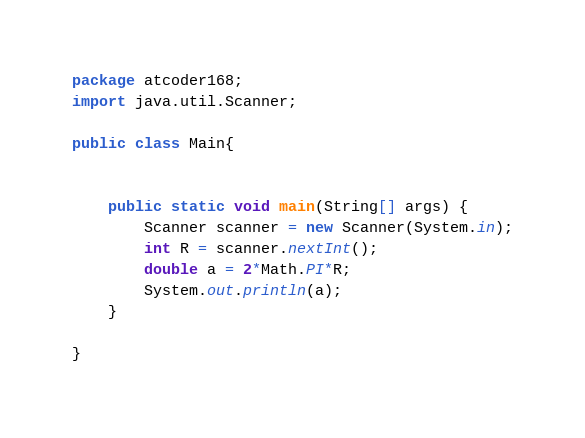Convert code to text. <code><loc_0><loc_0><loc_500><loc_500><_Java_>
package atcoder168;
import java.util.Scanner;

public class Main{

  
    public static void main(String[] args) {
        Scanner scanner = new Scanner(System.in);
        int R = scanner.nextInt();
        double a = 2*Math.PI*R; 
        System.out.println(a);
    }
    
}
</code> 